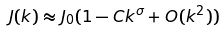Convert formula to latex. <formula><loc_0><loc_0><loc_500><loc_500>J ( { k } ) \approx J _ { 0 } ( 1 - C k ^ { \sigma } + O ( k ^ { 2 } ) )</formula> 